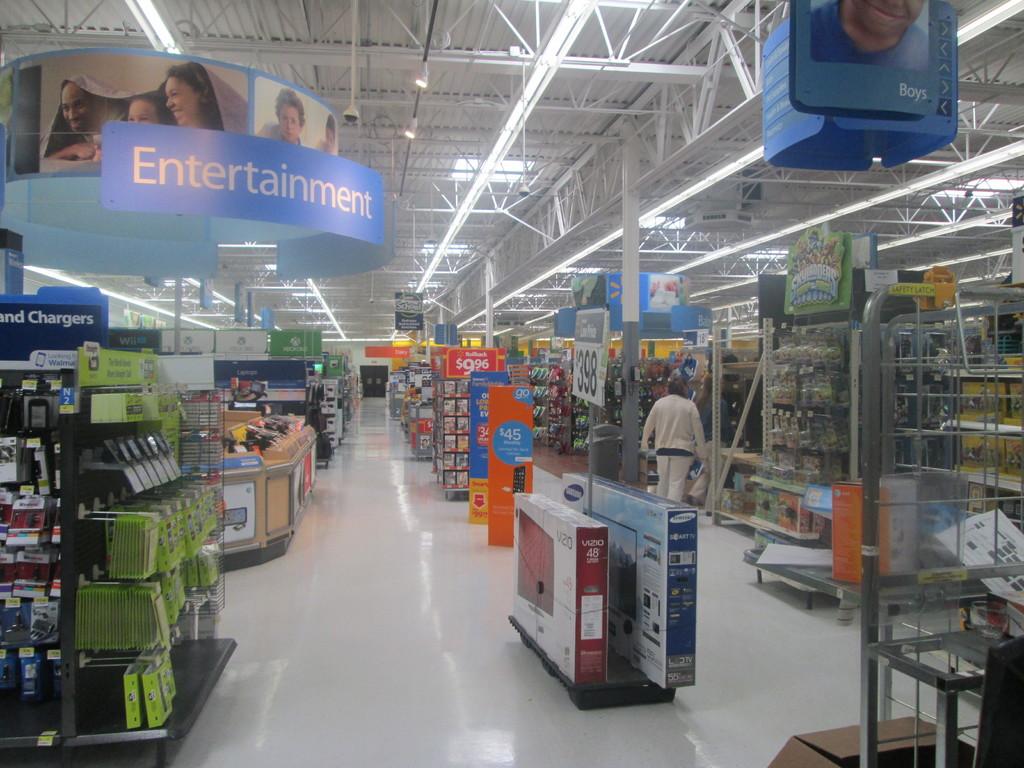What section is the large blue sign?
Make the answer very short. Entertainment. What section does it say on the very top right corner of the picture?
Give a very brief answer. Boys. 